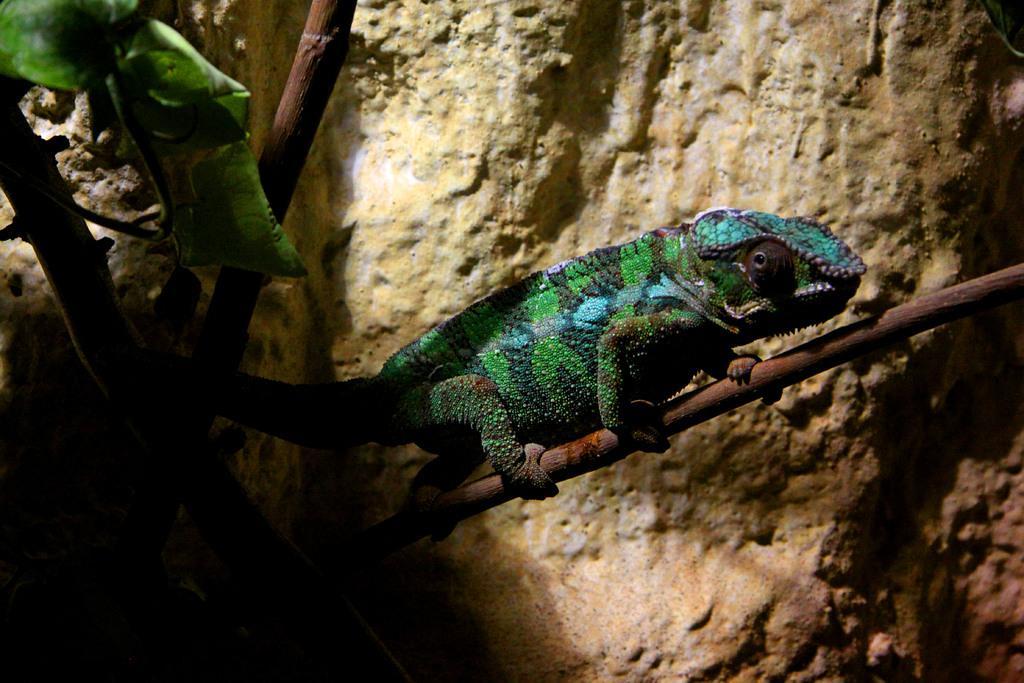Describe this image in one or two sentences. In this picture we can see green and blue chameleon, sitting on the plant branch. Behind we can see brown rock. 